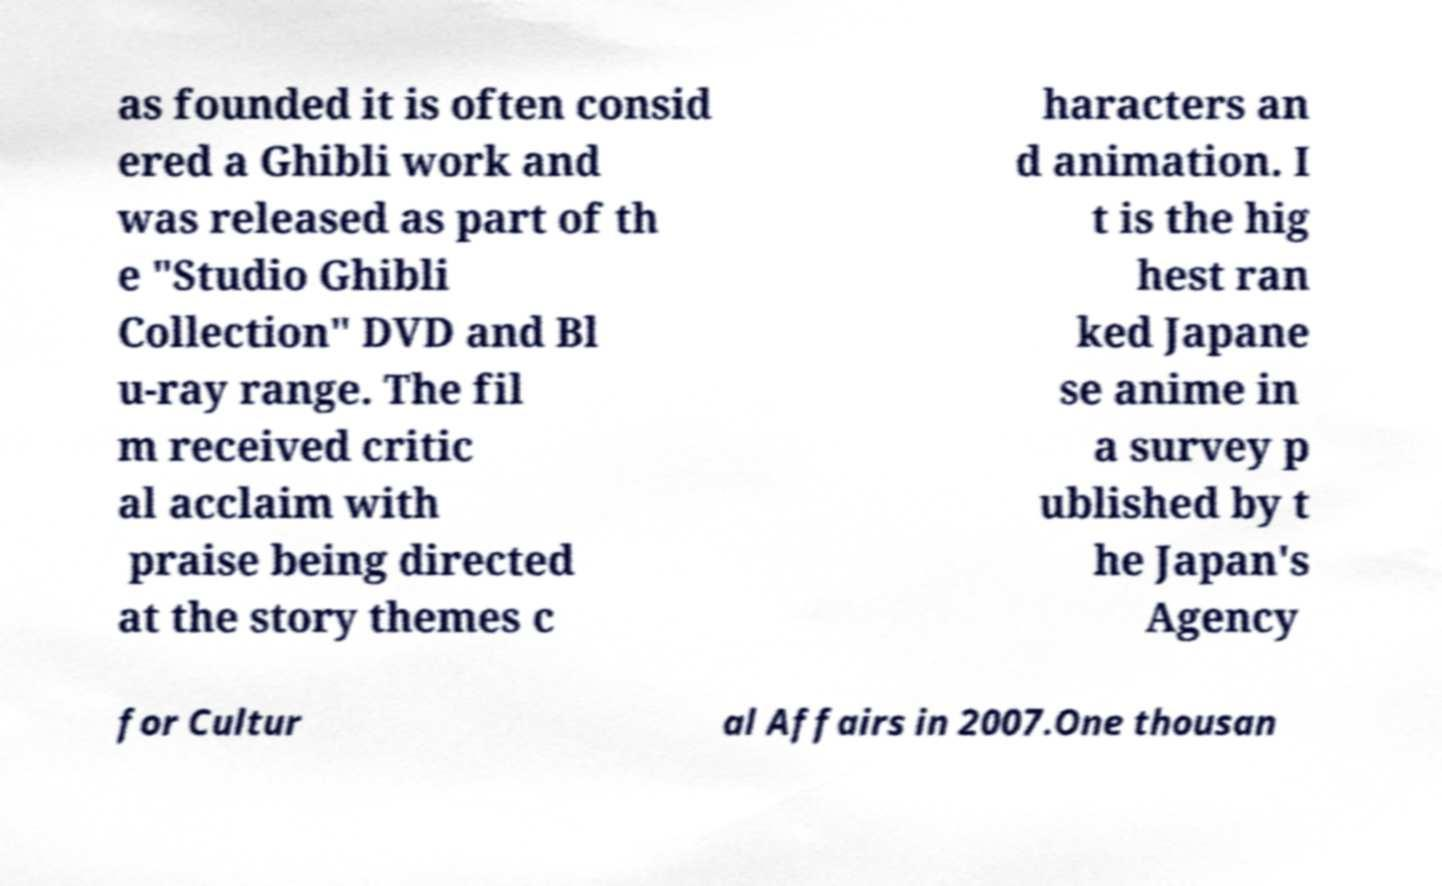Please identify and transcribe the text found in this image. as founded it is often consid ered a Ghibli work and was released as part of th e "Studio Ghibli Collection" DVD and Bl u-ray range. The fil m received critic al acclaim with praise being directed at the story themes c haracters an d animation. I t is the hig hest ran ked Japane se anime in a survey p ublished by t he Japan's Agency for Cultur al Affairs in 2007.One thousan 